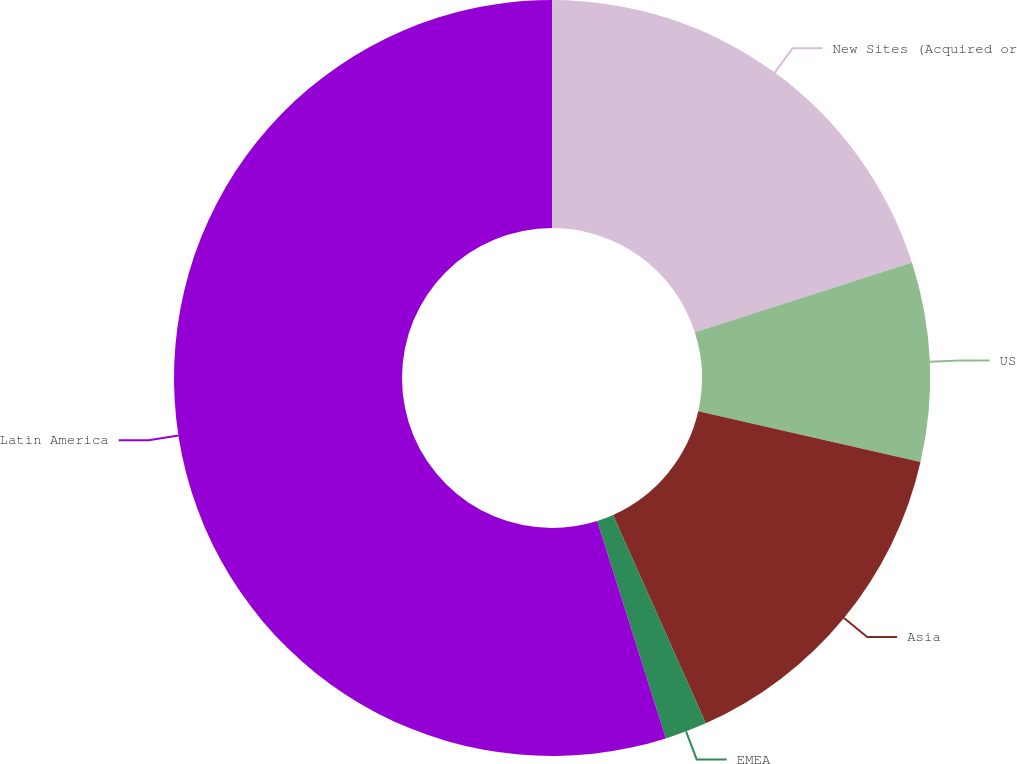Convert chart to OTSL. <chart><loc_0><loc_0><loc_500><loc_500><pie_chart><fcel>New Sites (Acquired or<fcel>US<fcel>Asia<fcel>EMEA<fcel>Latin America<nl><fcel>20.06%<fcel>8.51%<fcel>14.76%<fcel>1.8%<fcel>54.87%<nl></chart> 